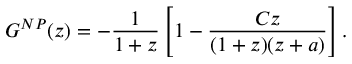Convert formula to latex. <formula><loc_0><loc_0><loc_500><loc_500>G ^ { N P } ( z ) = - { \frac { 1 } { 1 + z } } \left [ 1 - { \frac { C z } { ( 1 + z ) ( z + a ) } } \right ] .</formula> 